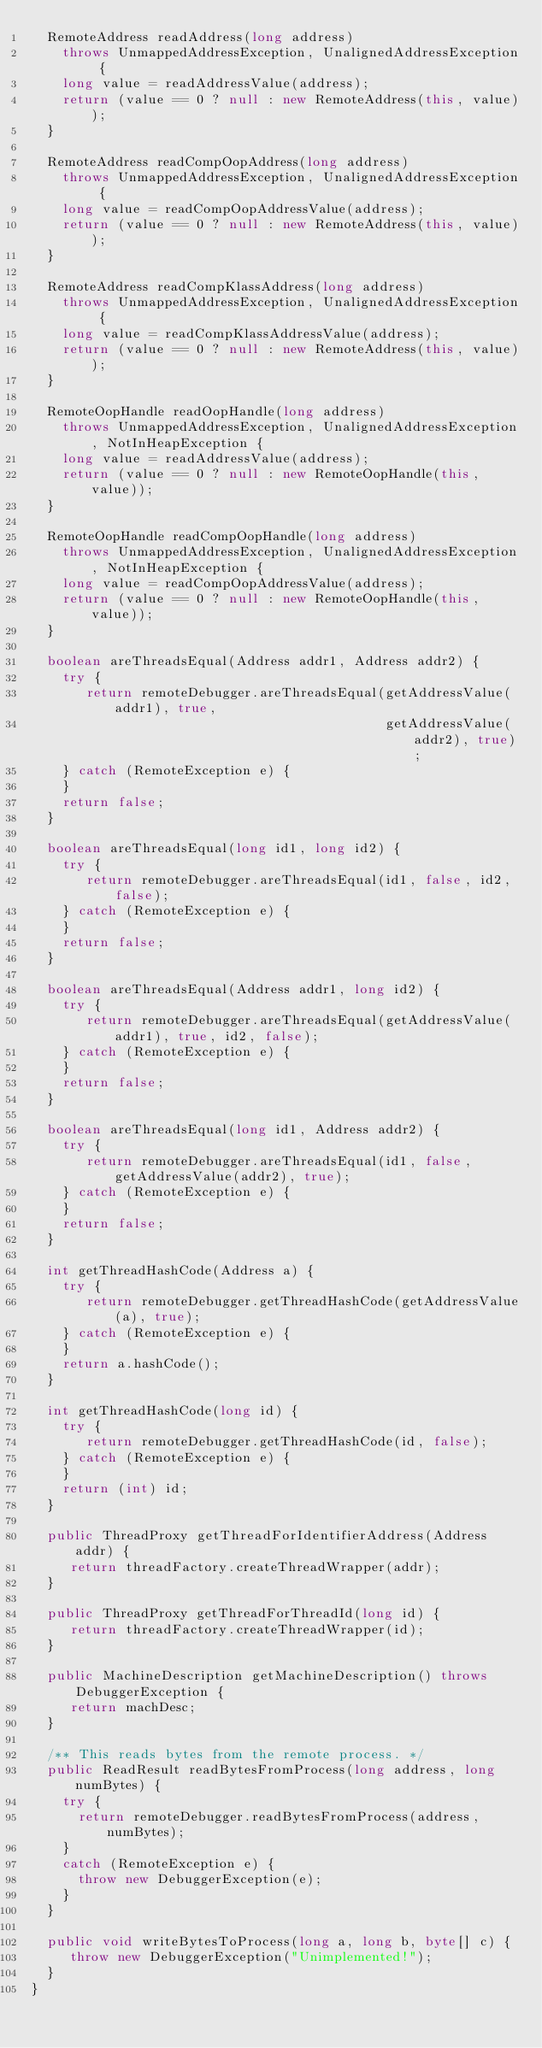Convert code to text. <code><loc_0><loc_0><loc_500><loc_500><_Java_>  RemoteAddress readAddress(long address)
    throws UnmappedAddressException, UnalignedAddressException {
    long value = readAddressValue(address);
    return (value == 0 ? null : new RemoteAddress(this, value));
  }

  RemoteAddress readCompOopAddress(long address)
    throws UnmappedAddressException, UnalignedAddressException {
    long value = readCompOopAddressValue(address);
    return (value == 0 ? null : new RemoteAddress(this, value));
  }

  RemoteAddress readCompKlassAddress(long address)
    throws UnmappedAddressException, UnalignedAddressException {
    long value = readCompKlassAddressValue(address);
    return (value == 0 ? null : new RemoteAddress(this, value));
  }

  RemoteOopHandle readOopHandle(long address)
    throws UnmappedAddressException, UnalignedAddressException, NotInHeapException {
    long value = readAddressValue(address);
    return (value == 0 ? null : new RemoteOopHandle(this, value));
  }

  RemoteOopHandle readCompOopHandle(long address)
    throws UnmappedAddressException, UnalignedAddressException, NotInHeapException {
    long value = readCompOopAddressValue(address);
    return (value == 0 ? null : new RemoteOopHandle(this, value));
  }

  boolean areThreadsEqual(Address addr1, Address addr2) {
    try {
       return remoteDebugger.areThreadsEqual(getAddressValue(addr1), true,
                                             getAddressValue(addr2), true);
    } catch (RemoteException e) {
    }
    return false;
  }

  boolean areThreadsEqual(long id1, long id2) {
    try {
       return remoteDebugger.areThreadsEqual(id1, false, id2, false);
    } catch (RemoteException e) {
    }
    return false;
  }

  boolean areThreadsEqual(Address addr1, long id2) {
    try {
       return remoteDebugger.areThreadsEqual(getAddressValue(addr1), true, id2, false);
    } catch (RemoteException e) {
    }
    return false;
  }

  boolean areThreadsEqual(long id1, Address addr2) {
    try {
       return remoteDebugger.areThreadsEqual(id1, false, getAddressValue(addr2), true);
    } catch (RemoteException e) {
    }
    return false;
  }

  int getThreadHashCode(Address a) {
    try {
       return remoteDebugger.getThreadHashCode(getAddressValue(a), true);
    } catch (RemoteException e) {
    }
    return a.hashCode();
  }

  int getThreadHashCode(long id) {
    try {
       return remoteDebugger.getThreadHashCode(id, false);
    } catch (RemoteException e) {
    }
    return (int) id;
  }

  public ThreadProxy getThreadForIdentifierAddress(Address addr) {
     return threadFactory.createThreadWrapper(addr);
  }

  public ThreadProxy getThreadForThreadId(long id) {
     return threadFactory.createThreadWrapper(id);
  }

  public MachineDescription getMachineDescription() throws DebuggerException {
     return machDesc;
  }

  /** This reads bytes from the remote process. */
  public ReadResult readBytesFromProcess(long address, long numBytes) {
    try {
      return remoteDebugger.readBytesFromProcess(address, numBytes);
    }
    catch (RemoteException e) {
      throw new DebuggerException(e);
    }
  }

  public void writeBytesToProcess(long a, long b, byte[] c) {
     throw new DebuggerException("Unimplemented!");
  }
}
</code> 